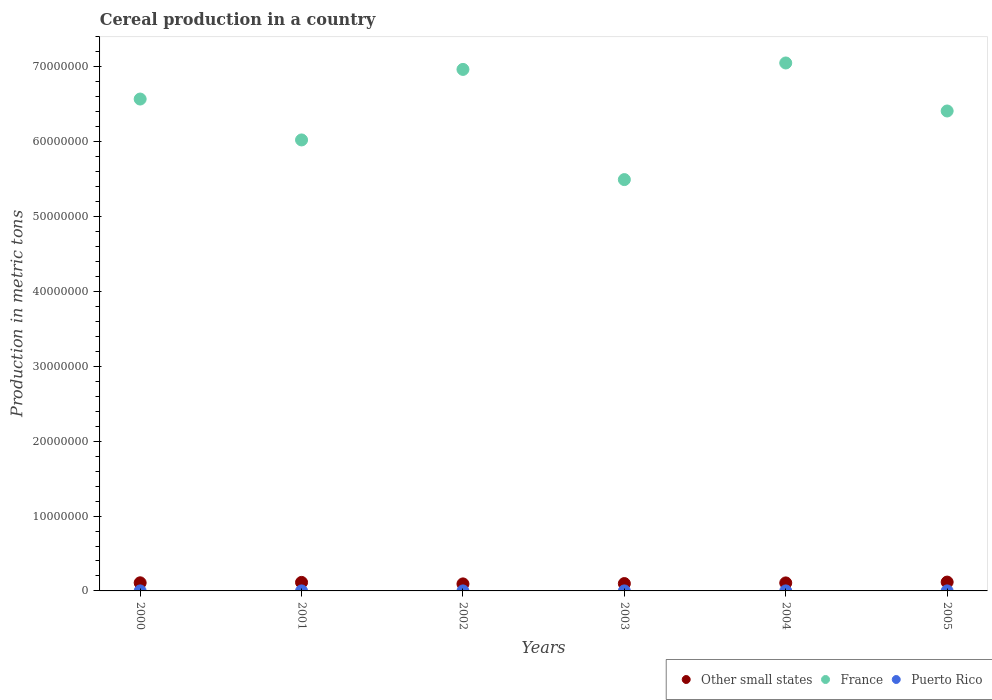Is the number of dotlines equal to the number of legend labels?
Ensure brevity in your answer.  Yes. What is the total cereal production in Puerto Rico in 2002?
Give a very brief answer. 469. Across all years, what is the maximum total cereal production in Other small states?
Offer a terse response. 1.18e+06. Across all years, what is the minimum total cereal production in Other small states?
Offer a terse response. 9.38e+05. What is the total total cereal production in France in the graph?
Provide a succinct answer. 3.85e+08. What is the difference between the total cereal production in France in 2000 and that in 2003?
Provide a short and direct response. 1.08e+07. What is the difference between the total cereal production in Puerto Rico in 2002 and the total cereal production in Other small states in 2000?
Offer a very short reply. -1.08e+06. What is the average total cereal production in France per year?
Keep it short and to the point. 6.42e+07. In the year 2002, what is the difference between the total cereal production in Other small states and total cereal production in France?
Offer a terse response. -6.87e+07. In how many years, is the total cereal production in Puerto Rico greater than 64000000 metric tons?
Offer a terse response. 0. What is the ratio of the total cereal production in France in 2002 to that in 2004?
Provide a succinct answer. 0.99. Is the total cereal production in France in 2001 less than that in 2004?
Give a very brief answer. Yes. Is the difference between the total cereal production in Other small states in 2001 and 2005 greater than the difference between the total cereal production in France in 2001 and 2005?
Make the answer very short. Yes. What is the difference between the highest and the second highest total cereal production in Other small states?
Your answer should be compact. 4.06e+04. What is the difference between the highest and the lowest total cereal production in France?
Provide a succinct answer. 1.56e+07. Is it the case that in every year, the sum of the total cereal production in France and total cereal production in Puerto Rico  is greater than the total cereal production in Other small states?
Make the answer very short. Yes. Is the total cereal production in France strictly greater than the total cereal production in Puerto Rico over the years?
Ensure brevity in your answer.  Yes. Is the total cereal production in Puerto Rico strictly less than the total cereal production in Other small states over the years?
Ensure brevity in your answer.  Yes. How many dotlines are there?
Provide a short and direct response. 3. Are the values on the major ticks of Y-axis written in scientific E-notation?
Provide a short and direct response. No. Does the graph contain grids?
Ensure brevity in your answer.  No. Where does the legend appear in the graph?
Provide a short and direct response. Bottom right. What is the title of the graph?
Offer a terse response. Cereal production in a country. What is the label or title of the Y-axis?
Your answer should be compact. Production in metric tons. What is the Production in metric tons in Other small states in 2000?
Your answer should be very brief. 1.08e+06. What is the Production in metric tons of France in 2000?
Keep it short and to the point. 6.57e+07. What is the Production in metric tons of Puerto Rico in 2000?
Your response must be concise. 450. What is the Production in metric tons in Other small states in 2001?
Ensure brevity in your answer.  1.14e+06. What is the Production in metric tons of France in 2001?
Offer a very short reply. 6.02e+07. What is the Production in metric tons in Puerto Rico in 2001?
Give a very brief answer. 465. What is the Production in metric tons of Other small states in 2002?
Your answer should be very brief. 9.38e+05. What is the Production in metric tons in France in 2002?
Offer a terse response. 6.97e+07. What is the Production in metric tons of Puerto Rico in 2002?
Give a very brief answer. 469. What is the Production in metric tons in Other small states in 2003?
Provide a short and direct response. 9.82e+05. What is the Production in metric tons of France in 2003?
Offer a terse response. 5.49e+07. What is the Production in metric tons of Puerto Rico in 2003?
Your answer should be very brief. 529. What is the Production in metric tons in Other small states in 2004?
Your answer should be very brief. 1.07e+06. What is the Production in metric tons of France in 2004?
Give a very brief answer. 7.05e+07. What is the Production in metric tons in Puerto Rico in 2004?
Your answer should be compact. 572. What is the Production in metric tons of Other small states in 2005?
Offer a terse response. 1.18e+06. What is the Production in metric tons in France in 2005?
Give a very brief answer. 6.41e+07. What is the Production in metric tons of Puerto Rico in 2005?
Your response must be concise. 543. Across all years, what is the maximum Production in metric tons of Other small states?
Ensure brevity in your answer.  1.18e+06. Across all years, what is the maximum Production in metric tons of France?
Give a very brief answer. 7.05e+07. Across all years, what is the maximum Production in metric tons in Puerto Rico?
Make the answer very short. 572. Across all years, what is the minimum Production in metric tons in Other small states?
Make the answer very short. 9.38e+05. Across all years, what is the minimum Production in metric tons of France?
Provide a succinct answer. 5.49e+07. Across all years, what is the minimum Production in metric tons in Puerto Rico?
Give a very brief answer. 450. What is the total Production in metric tons in Other small states in the graph?
Your answer should be very brief. 6.39e+06. What is the total Production in metric tons in France in the graph?
Give a very brief answer. 3.85e+08. What is the total Production in metric tons in Puerto Rico in the graph?
Your answer should be compact. 3028. What is the difference between the Production in metric tons of Other small states in 2000 and that in 2001?
Provide a succinct answer. -5.45e+04. What is the difference between the Production in metric tons of France in 2000 and that in 2001?
Make the answer very short. 5.46e+06. What is the difference between the Production in metric tons in Other small states in 2000 and that in 2002?
Make the answer very short. 1.47e+05. What is the difference between the Production in metric tons of France in 2000 and that in 2002?
Make the answer very short. -3.96e+06. What is the difference between the Production in metric tons of Other small states in 2000 and that in 2003?
Give a very brief answer. 1.03e+05. What is the difference between the Production in metric tons in France in 2000 and that in 2003?
Your answer should be very brief. 1.08e+07. What is the difference between the Production in metric tons of Puerto Rico in 2000 and that in 2003?
Provide a succinct answer. -79. What is the difference between the Production in metric tons in Other small states in 2000 and that in 2004?
Your response must be concise. 1.51e+04. What is the difference between the Production in metric tons of France in 2000 and that in 2004?
Offer a terse response. -4.82e+06. What is the difference between the Production in metric tons in Puerto Rico in 2000 and that in 2004?
Provide a succinct answer. -122. What is the difference between the Production in metric tons in Other small states in 2000 and that in 2005?
Give a very brief answer. -9.51e+04. What is the difference between the Production in metric tons in France in 2000 and that in 2005?
Give a very brief answer. 1.59e+06. What is the difference between the Production in metric tons in Puerto Rico in 2000 and that in 2005?
Provide a short and direct response. -93. What is the difference between the Production in metric tons of Other small states in 2001 and that in 2002?
Your response must be concise. 2.02e+05. What is the difference between the Production in metric tons in France in 2001 and that in 2002?
Your answer should be compact. -9.42e+06. What is the difference between the Production in metric tons of Other small states in 2001 and that in 2003?
Provide a short and direct response. 1.58e+05. What is the difference between the Production in metric tons of France in 2001 and that in 2003?
Provide a succinct answer. 5.30e+06. What is the difference between the Production in metric tons of Puerto Rico in 2001 and that in 2003?
Your response must be concise. -64. What is the difference between the Production in metric tons of Other small states in 2001 and that in 2004?
Give a very brief answer. 6.97e+04. What is the difference between the Production in metric tons in France in 2001 and that in 2004?
Provide a succinct answer. -1.03e+07. What is the difference between the Production in metric tons of Puerto Rico in 2001 and that in 2004?
Your response must be concise. -107. What is the difference between the Production in metric tons in Other small states in 2001 and that in 2005?
Offer a very short reply. -4.06e+04. What is the difference between the Production in metric tons in France in 2001 and that in 2005?
Give a very brief answer. -3.87e+06. What is the difference between the Production in metric tons of Puerto Rico in 2001 and that in 2005?
Give a very brief answer. -78. What is the difference between the Production in metric tons of Other small states in 2002 and that in 2003?
Keep it short and to the point. -4.39e+04. What is the difference between the Production in metric tons in France in 2002 and that in 2003?
Offer a terse response. 1.47e+07. What is the difference between the Production in metric tons in Puerto Rico in 2002 and that in 2003?
Provide a short and direct response. -60. What is the difference between the Production in metric tons of Other small states in 2002 and that in 2004?
Give a very brief answer. -1.32e+05. What is the difference between the Production in metric tons in France in 2002 and that in 2004?
Provide a short and direct response. -8.60e+05. What is the difference between the Production in metric tons of Puerto Rico in 2002 and that in 2004?
Your response must be concise. -103. What is the difference between the Production in metric tons in Other small states in 2002 and that in 2005?
Your answer should be very brief. -2.42e+05. What is the difference between the Production in metric tons in France in 2002 and that in 2005?
Offer a terse response. 5.55e+06. What is the difference between the Production in metric tons in Puerto Rico in 2002 and that in 2005?
Your answer should be compact. -74. What is the difference between the Production in metric tons of Other small states in 2003 and that in 2004?
Offer a very short reply. -8.79e+04. What is the difference between the Production in metric tons of France in 2003 and that in 2004?
Keep it short and to the point. -1.56e+07. What is the difference between the Production in metric tons of Puerto Rico in 2003 and that in 2004?
Your answer should be compact. -43. What is the difference between the Production in metric tons of Other small states in 2003 and that in 2005?
Your response must be concise. -1.98e+05. What is the difference between the Production in metric tons of France in 2003 and that in 2005?
Your response must be concise. -9.16e+06. What is the difference between the Production in metric tons of Puerto Rico in 2003 and that in 2005?
Keep it short and to the point. -14. What is the difference between the Production in metric tons in Other small states in 2004 and that in 2005?
Your response must be concise. -1.10e+05. What is the difference between the Production in metric tons of France in 2004 and that in 2005?
Keep it short and to the point. 6.41e+06. What is the difference between the Production in metric tons in Other small states in 2000 and the Production in metric tons in France in 2001?
Provide a succinct answer. -5.92e+07. What is the difference between the Production in metric tons in Other small states in 2000 and the Production in metric tons in Puerto Rico in 2001?
Your answer should be compact. 1.08e+06. What is the difference between the Production in metric tons of France in 2000 and the Production in metric tons of Puerto Rico in 2001?
Offer a very short reply. 6.57e+07. What is the difference between the Production in metric tons in Other small states in 2000 and the Production in metric tons in France in 2002?
Your response must be concise. -6.86e+07. What is the difference between the Production in metric tons of Other small states in 2000 and the Production in metric tons of Puerto Rico in 2002?
Make the answer very short. 1.08e+06. What is the difference between the Production in metric tons in France in 2000 and the Production in metric tons in Puerto Rico in 2002?
Ensure brevity in your answer.  6.57e+07. What is the difference between the Production in metric tons of Other small states in 2000 and the Production in metric tons of France in 2003?
Your response must be concise. -5.39e+07. What is the difference between the Production in metric tons in Other small states in 2000 and the Production in metric tons in Puerto Rico in 2003?
Ensure brevity in your answer.  1.08e+06. What is the difference between the Production in metric tons of France in 2000 and the Production in metric tons of Puerto Rico in 2003?
Offer a terse response. 6.57e+07. What is the difference between the Production in metric tons in Other small states in 2000 and the Production in metric tons in France in 2004?
Keep it short and to the point. -6.94e+07. What is the difference between the Production in metric tons in Other small states in 2000 and the Production in metric tons in Puerto Rico in 2004?
Your answer should be very brief. 1.08e+06. What is the difference between the Production in metric tons in France in 2000 and the Production in metric tons in Puerto Rico in 2004?
Provide a succinct answer. 6.57e+07. What is the difference between the Production in metric tons in Other small states in 2000 and the Production in metric tons in France in 2005?
Your response must be concise. -6.30e+07. What is the difference between the Production in metric tons in Other small states in 2000 and the Production in metric tons in Puerto Rico in 2005?
Keep it short and to the point. 1.08e+06. What is the difference between the Production in metric tons of France in 2000 and the Production in metric tons of Puerto Rico in 2005?
Offer a terse response. 6.57e+07. What is the difference between the Production in metric tons in Other small states in 2001 and the Production in metric tons in France in 2002?
Offer a terse response. -6.85e+07. What is the difference between the Production in metric tons of Other small states in 2001 and the Production in metric tons of Puerto Rico in 2002?
Provide a short and direct response. 1.14e+06. What is the difference between the Production in metric tons in France in 2001 and the Production in metric tons in Puerto Rico in 2002?
Keep it short and to the point. 6.02e+07. What is the difference between the Production in metric tons in Other small states in 2001 and the Production in metric tons in France in 2003?
Offer a terse response. -5.38e+07. What is the difference between the Production in metric tons of Other small states in 2001 and the Production in metric tons of Puerto Rico in 2003?
Your answer should be compact. 1.14e+06. What is the difference between the Production in metric tons of France in 2001 and the Production in metric tons of Puerto Rico in 2003?
Your response must be concise. 6.02e+07. What is the difference between the Production in metric tons of Other small states in 2001 and the Production in metric tons of France in 2004?
Provide a short and direct response. -6.94e+07. What is the difference between the Production in metric tons of Other small states in 2001 and the Production in metric tons of Puerto Rico in 2004?
Provide a short and direct response. 1.14e+06. What is the difference between the Production in metric tons of France in 2001 and the Production in metric tons of Puerto Rico in 2004?
Give a very brief answer. 6.02e+07. What is the difference between the Production in metric tons of Other small states in 2001 and the Production in metric tons of France in 2005?
Your answer should be compact. -6.30e+07. What is the difference between the Production in metric tons in Other small states in 2001 and the Production in metric tons in Puerto Rico in 2005?
Offer a very short reply. 1.14e+06. What is the difference between the Production in metric tons of France in 2001 and the Production in metric tons of Puerto Rico in 2005?
Provide a short and direct response. 6.02e+07. What is the difference between the Production in metric tons in Other small states in 2002 and the Production in metric tons in France in 2003?
Provide a succinct answer. -5.40e+07. What is the difference between the Production in metric tons of Other small states in 2002 and the Production in metric tons of Puerto Rico in 2003?
Your answer should be compact. 9.37e+05. What is the difference between the Production in metric tons of France in 2002 and the Production in metric tons of Puerto Rico in 2003?
Make the answer very short. 6.97e+07. What is the difference between the Production in metric tons of Other small states in 2002 and the Production in metric tons of France in 2004?
Provide a short and direct response. -6.96e+07. What is the difference between the Production in metric tons of Other small states in 2002 and the Production in metric tons of Puerto Rico in 2004?
Keep it short and to the point. 9.37e+05. What is the difference between the Production in metric tons of France in 2002 and the Production in metric tons of Puerto Rico in 2004?
Provide a short and direct response. 6.97e+07. What is the difference between the Production in metric tons in Other small states in 2002 and the Production in metric tons in France in 2005?
Ensure brevity in your answer.  -6.32e+07. What is the difference between the Production in metric tons of Other small states in 2002 and the Production in metric tons of Puerto Rico in 2005?
Ensure brevity in your answer.  9.37e+05. What is the difference between the Production in metric tons of France in 2002 and the Production in metric tons of Puerto Rico in 2005?
Your answer should be very brief. 6.97e+07. What is the difference between the Production in metric tons of Other small states in 2003 and the Production in metric tons of France in 2004?
Your answer should be very brief. -6.95e+07. What is the difference between the Production in metric tons of Other small states in 2003 and the Production in metric tons of Puerto Rico in 2004?
Offer a terse response. 9.81e+05. What is the difference between the Production in metric tons of France in 2003 and the Production in metric tons of Puerto Rico in 2004?
Offer a terse response. 5.49e+07. What is the difference between the Production in metric tons of Other small states in 2003 and the Production in metric tons of France in 2005?
Provide a succinct answer. -6.31e+07. What is the difference between the Production in metric tons of Other small states in 2003 and the Production in metric tons of Puerto Rico in 2005?
Provide a short and direct response. 9.81e+05. What is the difference between the Production in metric tons in France in 2003 and the Production in metric tons in Puerto Rico in 2005?
Offer a very short reply. 5.49e+07. What is the difference between the Production in metric tons of Other small states in 2004 and the Production in metric tons of France in 2005?
Offer a terse response. -6.30e+07. What is the difference between the Production in metric tons in Other small states in 2004 and the Production in metric tons in Puerto Rico in 2005?
Offer a very short reply. 1.07e+06. What is the difference between the Production in metric tons of France in 2004 and the Production in metric tons of Puerto Rico in 2005?
Give a very brief answer. 7.05e+07. What is the average Production in metric tons in Other small states per year?
Offer a terse response. 1.07e+06. What is the average Production in metric tons in France per year?
Your response must be concise. 6.42e+07. What is the average Production in metric tons in Puerto Rico per year?
Offer a terse response. 504.67. In the year 2000, what is the difference between the Production in metric tons in Other small states and Production in metric tons in France?
Ensure brevity in your answer.  -6.46e+07. In the year 2000, what is the difference between the Production in metric tons of Other small states and Production in metric tons of Puerto Rico?
Ensure brevity in your answer.  1.08e+06. In the year 2000, what is the difference between the Production in metric tons in France and Production in metric tons in Puerto Rico?
Keep it short and to the point. 6.57e+07. In the year 2001, what is the difference between the Production in metric tons of Other small states and Production in metric tons of France?
Provide a succinct answer. -5.91e+07. In the year 2001, what is the difference between the Production in metric tons of Other small states and Production in metric tons of Puerto Rico?
Offer a terse response. 1.14e+06. In the year 2001, what is the difference between the Production in metric tons in France and Production in metric tons in Puerto Rico?
Your answer should be very brief. 6.02e+07. In the year 2002, what is the difference between the Production in metric tons of Other small states and Production in metric tons of France?
Give a very brief answer. -6.87e+07. In the year 2002, what is the difference between the Production in metric tons in Other small states and Production in metric tons in Puerto Rico?
Offer a very short reply. 9.37e+05. In the year 2002, what is the difference between the Production in metric tons in France and Production in metric tons in Puerto Rico?
Offer a terse response. 6.97e+07. In the year 2003, what is the difference between the Production in metric tons of Other small states and Production in metric tons of France?
Offer a terse response. -5.40e+07. In the year 2003, what is the difference between the Production in metric tons of Other small states and Production in metric tons of Puerto Rico?
Offer a terse response. 9.81e+05. In the year 2003, what is the difference between the Production in metric tons of France and Production in metric tons of Puerto Rico?
Keep it short and to the point. 5.49e+07. In the year 2004, what is the difference between the Production in metric tons in Other small states and Production in metric tons in France?
Keep it short and to the point. -6.94e+07. In the year 2004, what is the difference between the Production in metric tons in Other small states and Production in metric tons in Puerto Rico?
Your response must be concise. 1.07e+06. In the year 2004, what is the difference between the Production in metric tons in France and Production in metric tons in Puerto Rico?
Give a very brief answer. 7.05e+07. In the year 2005, what is the difference between the Production in metric tons of Other small states and Production in metric tons of France?
Offer a terse response. -6.29e+07. In the year 2005, what is the difference between the Production in metric tons of Other small states and Production in metric tons of Puerto Rico?
Ensure brevity in your answer.  1.18e+06. In the year 2005, what is the difference between the Production in metric tons of France and Production in metric tons of Puerto Rico?
Offer a terse response. 6.41e+07. What is the ratio of the Production in metric tons of Other small states in 2000 to that in 2001?
Your answer should be very brief. 0.95. What is the ratio of the Production in metric tons of France in 2000 to that in 2001?
Provide a short and direct response. 1.09. What is the ratio of the Production in metric tons in Puerto Rico in 2000 to that in 2001?
Make the answer very short. 0.97. What is the ratio of the Production in metric tons in Other small states in 2000 to that in 2002?
Your answer should be compact. 1.16. What is the ratio of the Production in metric tons of France in 2000 to that in 2002?
Offer a very short reply. 0.94. What is the ratio of the Production in metric tons in Puerto Rico in 2000 to that in 2002?
Keep it short and to the point. 0.96. What is the ratio of the Production in metric tons of Other small states in 2000 to that in 2003?
Ensure brevity in your answer.  1.1. What is the ratio of the Production in metric tons in France in 2000 to that in 2003?
Your answer should be compact. 1.2. What is the ratio of the Production in metric tons of Puerto Rico in 2000 to that in 2003?
Make the answer very short. 0.85. What is the ratio of the Production in metric tons of Other small states in 2000 to that in 2004?
Ensure brevity in your answer.  1.01. What is the ratio of the Production in metric tons of France in 2000 to that in 2004?
Make the answer very short. 0.93. What is the ratio of the Production in metric tons of Puerto Rico in 2000 to that in 2004?
Keep it short and to the point. 0.79. What is the ratio of the Production in metric tons in Other small states in 2000 to that in 2005?
Your answer should be very brief. 0.92. What is the ratio of the Production in metric tons in France in 2000 to that in 2005?
Provide a short and direct response. 1.02. What is the ratio of the Production in metric tons of Puerto Rico in 2000 to that in 2005?
Your answer should be compact. 0.83. What is the ratio of the Production in metric tons in Other small states in 2001 to that in 2002?
Your answer should be compact. 1.21. What is the ratio of the Production in metric tons in France in 2001 to that in 2002?
Provide a short and direct response. 0.86. What is the ratio of the Production in metric tons in Puerto Rico in 2001 to that in 2002?
Ensure brevity in your answer.  0.99. What is the ratio of the Production in metric tons in Other small states in 2001 to that in 2003?
Give a very brief answer. 1.16. What is the ratio of the Production in metric tons in France in 2001 to that in 2003?
Offer a terse response. 1.1. What is the ratio of the Production in metric tons of Puerto Rico in 2001 to that in 2003?
Offer a very short reply. 0.88. What is the ratio of the Production in metric tons of Other small states in 2001 to that in 2004?
Provide a succinct answer. 1.07. What is the ratio of the Production in metric tons of France in 2001 to that in 2004?
Your response must be concise. 0.85. What is the ratio of the Production in metric tons of Puerto Rico in 2001 to that in 2004?
Your response must be concise. 0.81. What is the ratio of the Production in metric tons of Other small states in 2001 to that in 2005?
Provide a short and direct response. 0.97. What is the ratio of the Production in metric tons in France in 2001 to that in 2005?
Offer a terse response. 0.94. What is the ratio of the Production in metric tons in Puerto Rico in 2001 to that in 2005?
Provide a succinct answer. 0.86. What is the ratio of the Production in metric tons in Other small states in 2002 to that in 2003?
Ensure brevity in your answer.  0.96. What is the ratio of the Production in metric tons of France in 2002 to that in 2003?
Ensure brevity in your answer.  1.27. What is the ratio of the Production in metric tons in Puerto Rico in 2002 to that in 2003?
Offer a very short reply. 0.89. What is the ratio of the Production in metric tons of Other small states in 2002 to that in 2004?
Offer a very short reply. 0.88. What is the ratio of the Production in metric tons of France in 2002 to that in 2004?
Your response must be concise. 0.99. What is the ratio of the Production in metric tons of Puerto Rico in 2002 to that in 2004?
Your answer should be very brief. 0.82. What is the ratio of the Production in metric tons in Other small states in 2002 to that in 2005?
Your answer should be very brief. 0.79. What is the ratio of the Production in metric tons of France in 2002 to that in 2005?
Your answer should be very brief. 1.09. What is the ratio of the Production in metric tons in Puerto Rico in 2002 to that in 2005?
Provide a succinct answer. 0.86. What is the ratio of the Production in metric tons in Other small states in 2003 to that in 2004?
Offer a terse response. 0.92. What is the ratio of the Production in metric tons in France in 2003 to that in 2004?
Your answer should be compact. 0.78. What is the ratio of the Production in metric tons in Puerto Rico in 2003 to that in 2004?
Offer a terse response. 0.92. What is the ratio of the Production in metric tons in Other small states in 2003 to that in 2005?
Keep it short and to the point. 0.83. What is the ratio of the Production in metric tons in France in 2003 to that in 2005?
Give a very brief answer. 0.86. What is the ratio of the Production in metric tons of Puerto Rico in 2003 to that in 2005?
Offer a terse response. 0.97. What is the ratio of the Production in metric tons in Other small states in 2004 to that in 2005?
Your response must be concise. 0.91. What is the ratio of the Production in metric tons in France in 2004 to that in 2005?
Keep it short and to the point. 1.1. What is the ratio of the Production in metric tons in Puerto Rico in 2004 to that in 2005?
Ensure brevity in your answer.  1.05. What is the difference between the highest and the second highest Production in metric tons of Other small states?
Your answer should be compact. 4.06e+04. What is the difference between the highest and the second highest Production in metric tons of France?
Give a very brief answer. 8.60e+05. What is the difference between the highest and the lowest Production in metric tons of Other small states?
Provide a short and direct response. 2.42e+05. What is the difference between the highest and the lowest Production in metric tons of France?
Your answer should be compact. 1.56e+07. What is the difference between the highest and the lowest Production in metric tons in Puerto Rico?
Your answer should be very brief. 122. 